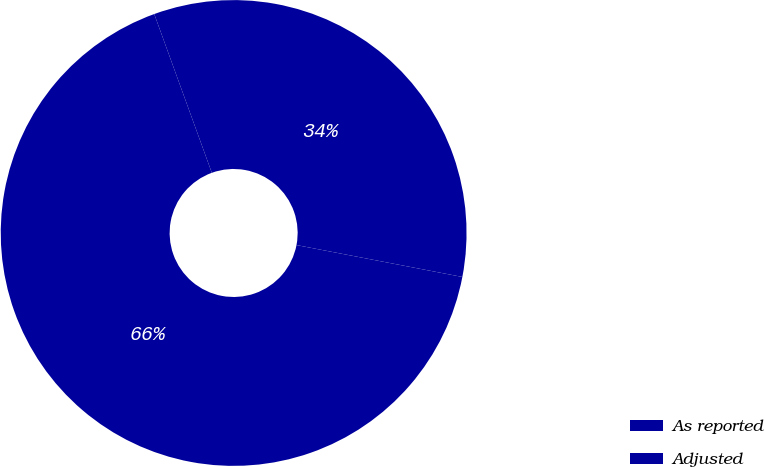Convert chart. <chart><loc_0><loc_0><loc_500><loc_500><pie_chart><fcel>As reported<fcel>Adjusted<nl><fcel>66.44%<fcel>33.56%<nl></chart> 